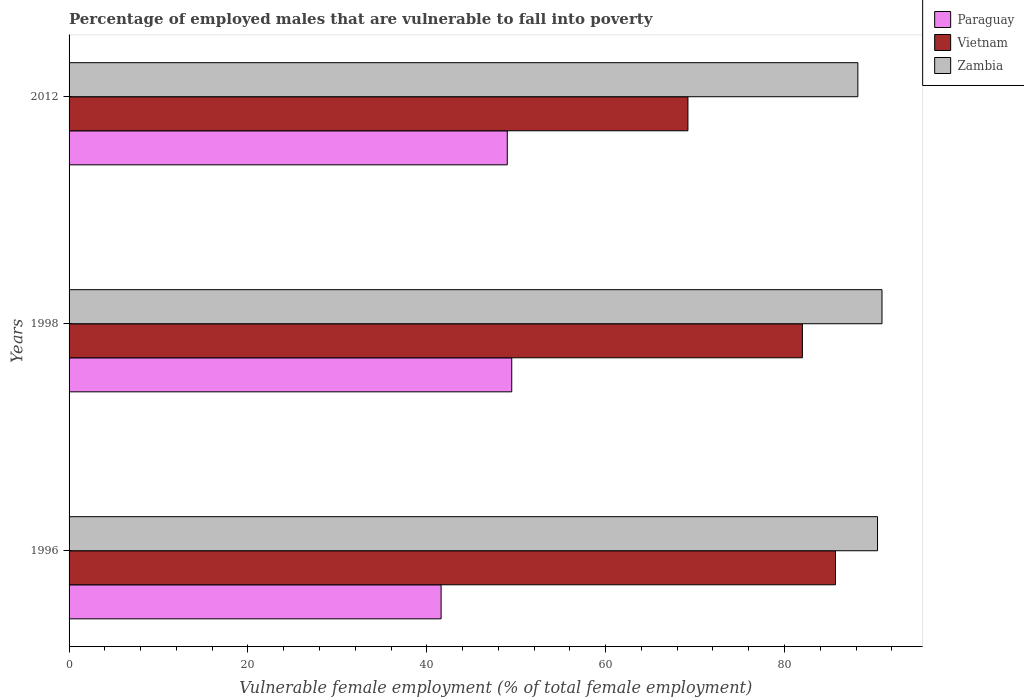How many different coloured bars are there?
Your answer should be very brief. 3. Are the number of bars per tick equal to the number of legend labels?
Give a very brief answer. Yes. How many bars are there on the 1st tick from the top?
Provide a succinct answer. 3. How many bars are there on the 2nd tick from the bottom?
Offer a terse response. 3. In how many cases, is the number of bars for a given year not equal to the number of legend labels?
Make the answer very short. 0. What is the percentage of employed males who are vulnerable to fall into poverty in Zambia in 2012?
Offer a very short reply. 88.2. Across all years, what is the maximum percentage of employed males who are vulnerable to fall into poverty in Paraguay?
Your answer should be compact. 49.5. Across all years, what is the minimum percentage of employed males who are vulnerable to fall into poverty in Paraguay?
Make the answer very short. 41.6. In which year was the percentage of employed males who are vulnerable to fall into poverty in Zambia maximum?
Ensure brevity in your answer.  1998. In which year was the percentage of employed males who are vulnerable to fall into poverty in Vietnam minimum?
Offer a terse response. 2012. What is the total percentage of employed males who are vulnerable to fall into poverty in Zambia in the graph?
Keep it short and to the point. 269.5. What is the difference between the percentage of employed males who are vulnerable to fall into poverty in Zambia in 1998 and that in 2012?
Offer a terse response. 2.7. What is the difference between the percentage of employed males who are vulnerable to fall into poverty in Zambia in 1996 and the percentage of employed males who are vulnerable to fall into poverty in Paraguay in 2012?
Your response must be concise. 41.4. What is the average percentage of employed males who are vulnerable to fall into poverty in Zambia per year?
Your answer should be very brief. 89.83. In the year 1998, what is the difference between the percentage of employed males who are vulnerable to fall into poverty in Zambia and percentage of employed males who are vulnerable to fall into poverty in Vietnam?
Ensure brevity in your answer.  8.9. In how many years, is the percentage of employed males who are vulnerable to fall into poverty in Vietnam greater than 64 %?
Provide a succinct answer. 3. What is the ratio of the percentage of employed males who are vulnerable to fall into poverty in Zambia in 1996 to that in 2012?
Your answer should be compact. 1.02. Is the percentage of employed males who are vulnerable to fall into poverty in Vietnam in 1996 less than that in 1998?
Make the answer very short. No. What is the difference between the highest and the lowest percentage of employed males who are vulnerable to fall into poverty in Paraguay?
Your response must be concise. 7.9. In how many years, is the percentage of employed males who are vulnerable to fall into poverty in Zambia greater than the average percentage of employed males who are vulnerable to fall into poverty in Zambia taken over all years?
Your answer should be compact. 2. Is the sum of the percentage of employed males who are vulnerable to fall into poverty in Paraguay in 1996 and 2012 greater than the maximum percentage of employed males who are vulnerable to fall into poverty in Vietnam across all years?
Keep it short and to the point. Yes. What does the 2nd bar from the top in 1998 represents?
Ensure brevity in your answer.  Vietnam. What does the 1st bar from the bottom in 1996 represents?
Offer a very short reply. Paraguay. How many bars are there?
Provide a short and direct response. 9. Are all the bars in the graph horizontal?
Ensure brevity in your answer.  Yes. How many years are there in the graph?
Offer a very short reply. 3. What is the difference between two consecutive major ticks on the X-axis?
Keep it short and to the point. 20. Are the values on the major ticks of X-axis written in scientific E-notation?
Make the answer very short. No. Does the graph contain grids?
Offer a terse response. No. How many legend labels are there?
Ensure brevity in your answer.  3. How are the legend labels stacked?
Your answer should be very brief. Vertical. What is the title of the graph?
Provide a succinct answer. Percentage of employed males that are vulnerable to fall into poverty. Does "Dominican Republic" appear as one of the legend labels in the graph?
Ensure brevity in your answer.  No. What is the label or title of the X-axis?
Provide a short and direct response. Vulnerable female employment (% of total female employment). What is the label or title of the Y-axis?
Offer a very short reply. Years. What is the Vulnerable female employment (% of total female employment) of Paraguay in 1996?
Give a very brief answer. 41.6. What is the Vulnerable female employment (% of total female employment) in Vietnam in 1996?
Your answer should be very brief. 85.7. What is the Vulnerable female employment (% of total female employment) of Zambia in 1996?
Provide a short and direct response. 90.4. What is the Vulnerable female employment (% of total female employment) of Paraguay in 1998?
Keep it short and to the point. 49.5. What is the Vulnerable female employment (% of total female employment) of Vietnam in 1998?
Offer a terse response. 82. What is the Vulnerable female employment (% of total female employment) of Zambia in 1998?
Give a very brief answer. 90.9. What is the Vulnerable female employment (% of total female employment) in Vietnam in 2012?
Offer a very short reply. 69.2. What is the Vulnerable female employment (% of total female employment) in Zambia in 2012?
Give a very brief answer. 88.2. Across all years, what is the maximum Vulnerable female employment (% of total female employment) in Paraguay?
Provide a short and direct response. 49.5. Across all years, what is the maximum Vulnerable female employment (% of total female employment) of Vietnam?
Give a very brief answer. 85.7. Across all years, what is the maximum Vulnerable female employment (% of total female employment) in Zambia?
Make the answer very short. 90.9. Across all years, what is the minimum Vulnerable female employment (% of total female employment) of Paraguay?
Your answer should be very brief. 41.6. Across all years, what is the minimum Vulnerable female employment (% of total female employment) in Vietnam?
Ensure brevity in your answer.  69.2. Across all years, what is the minimum Vulnerable female employment (% of total female employment) in Zambia?
Make the answer very short. 88.2. What is the total Vulnerable female employment (% of total female employment) of Paraguay in the graph?
Ensure brevity in your answer.  140.1. What is the total Vulnerable female employment (% of total female employment) of Vietnam in the graph?
Make the answer very short. 236.9. What is the total Vulnerable female employment (% of total female employment) in Zambia in the graph?
Provide a succinct answer. 269.5. What is the difference between the Vulnerable female employment (% of total female employment) of Paraguay in 1996 and that in 1998?
Provide a succinct answer. -7.9. What is the difference between the Vulnerable female employment (% of total female employment) in Zambia in 1996 and that in 1998?
Offer a terse response. -0.5. What is the difference between the Vulnerable female employment (% of total female employment) of Zambia in 1996 and that in 2012?
Make the answer very short. 2.2. What is the difference between the Vulnerable female employment (% of total female employment) in Vietnam in 1998 and that in 2012?
Keep it short and to the point. 12.8. What is the difference between the Vulnerable female employment (% of total female employment) of Paraguay in 1996 and the Vulnerable female employment (% of total female employment) of Vietnam in 1998?
Keep it short and to the point. -40.4. What is the difference between the Vulnerable female employment (% of total female employment) in Paraguay in 1996 and the Vulnerable female employment (% of total female employment) in Zambia in 1998?
Keep it short and to the point. -49.3. What is the difference between the Vulnerable female employment (% of total female employment) in Paraguay in 1996 and the Vulnerable female employment (% of total female employment) in Vietnam in 2012?
Your response must be concise. -27.6. What is the difference between the Vulnerable female employment (% of total female employment) in Paraguay in 1996 and the Vulnerable female employment (% of total female employment) in Zambia in 2012?
Your answer should be very brief. -46.6. What is the difference between the Vulnerable female employment (% of total female employment) in Paraguay in 1998 and the Vulnerable female employment (% of total female employment) in Vietnam in 2012?
Your response must be concise. -19.7. What is the difference between the Vulnerable female employment (% of total female employment) of Paraguay in 1998 and the Vulnerable female employment (% of total female employment) of Zambia in 2012?
Make the answer very short. -38.7. What is the average Vulnerable female employment (% of total female employment) of Paraguay per year?
Your answer should be compact. 46.7. What is the average Vulnerable female employment (% of total female employment) in Vietnam per year?
Give a very brief answer. 78.97. What is the average Vulnerable female employment (% of total female employment) in Zambia per year?
Give a very brief answer. 89.83. In the year 1996, what is the difference between the Vulnerable female employment (% of total female employment) of Paraguay and Vulnerable female employment (% of total female employment) of Vietnam?
Offer a terse response. -44.1. In the year 1996, what is the difference between the Vulnerable female employment (% of total female employment) of Paraguay and Vulnerable female employment (% of total female employment) of Zambia?
Your response must be concise. -48.8. In the year 1996, what is the difference between the Vulnerable female employment (% of total female employment) of Vietnam and Vulnerable female employment (% of total female employment) of Zambia?
Give a very brief answer. -4.7. In the year 1998, what is the difference between the Vulnerable female employment (% of total female employment) in Paraguay and Vulnerable female employment (% of total female employment) in Vietnam?
Your answer should be very brief. -32.5. In the year 1998, what is the difference between the Vulnerable female employment (% of total female employment) of Paraguay and Vulnerable female employment (% of total female employment) of Zambia?
Provide a succinct answer. -41.4. In the year 2012, what is the difference between the Vulnerable female employment (% of total female employment) of Paraguay and Vulnerable female employment (% of total female employment) of Vietnam?
Your answer should be compact. -20.2. In the year 2012, what is the difference between the Vulnerable female employment (% of total female employment) of Paraguay and Vulnerable female employment (% of total female employment) of Zambia?
Your answer should be very brief. -39.2. What is the ratio of the Vulnerable female employment (% of total female employment) of Paraguay in 1996 to that in 1998?
Offer a terse response. 0.84. What is the ratio of the Vulnerable female employment (% of total female employment) in Vietnam in 1996 to that in 1998?
Your answer should be compact. 1.05. What is the ratio of the Vulnerable female employment (% of total female employment) in Zambia in 1996 to that in 1998?
Provide a succinct answer. 0.99. What is the ratio of the Vulnerable female employment (% of total female employment) in Paraguay in 1996 to that in 2012?
Your response must be concise. 0.85. What is the ratio of the Vulnerable female employment (% of total female employment) in Vietnam in 1996 to that in 2012?
Your response must be concise. 1.24. What is the ratio of the Vulnerable female employment (% of total female employment) of Zambia in 1996 to that in 2012?
Give a very brief answer. 1.02. What is the ratio of the Vulnerable female employment (% of total female employment) of Paraguay in 1998 to that in 2012?
Offer a very short reply. 1.01. What is the ratio of the Vulnerable female employment (% of total female employment) in Vietnam in 1998 to that in 2012?
Your answer should be compact. 1.19. What is the ratio of the Vulnerable female employment (% of total female employment) in Zambia in 1998 to that in 2012?
Provide a short and direct response. 1.03. What is the difference between the highest and the second highest Vulnerable female employment (% of total female employment) of Vietnam?
Your response must be concise. 3.7. What is the difference between the highest and the lowest Vulnerable female employment (% of total female employment) in Paraguay?
Your answer should be compact. 7.9. What is the difference between the highest and the lowest Vulnerable female employment (% of total female employment) in Vietnam?
Your answer should be compact. 16.5. What is the difference between the highest and the lowest Vulnerable female employment (% of total female employment) in Zambia?
Your answer should be very brief. 2.7. 